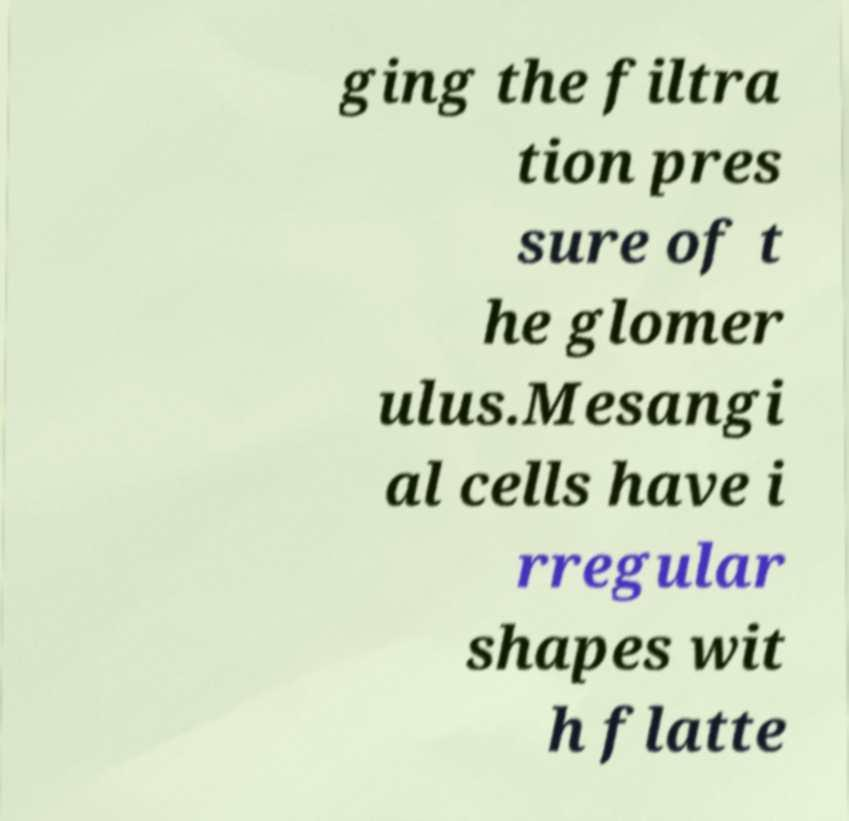Could you assist in decoding the text presented in this image and type it out clearly? ging the filtra tion pres sure of t he glomer ulus.Mesangi al cells have i rregular shapes wit h flatte 